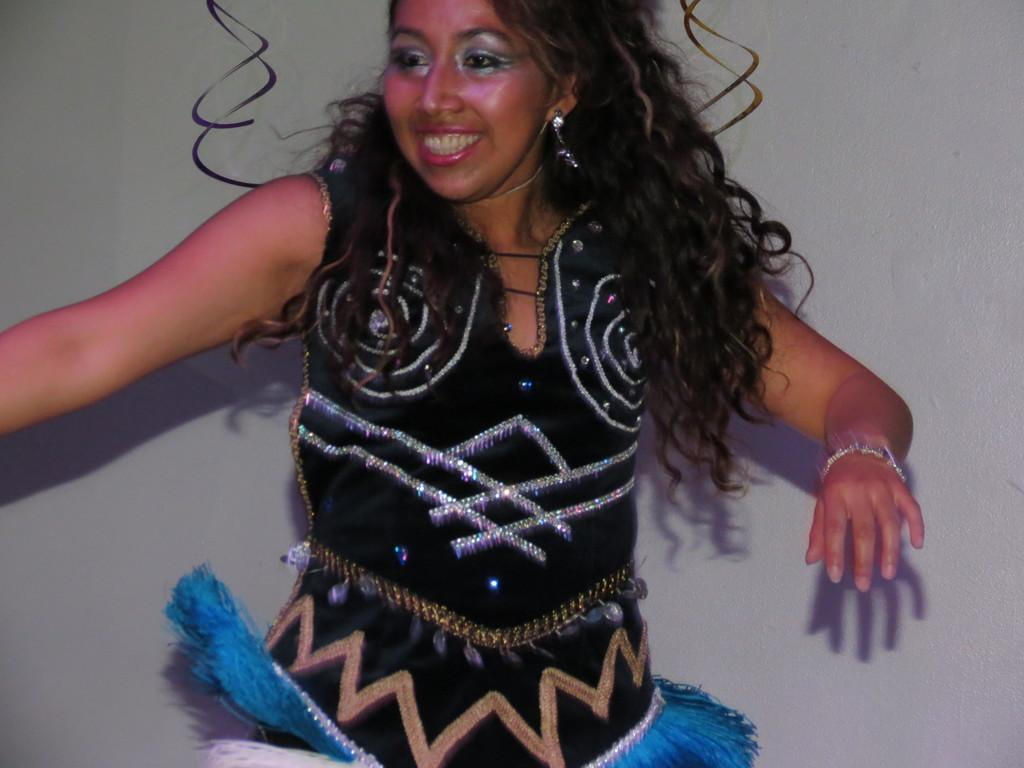Who is present in the image? There is a woman in the image. What type of sign is the woman holding in the image? There is no sign present in the image; only the woman is visible. What boundary is the woman standing near in the image? There is no boundary present in the image; only the woman is visible. 